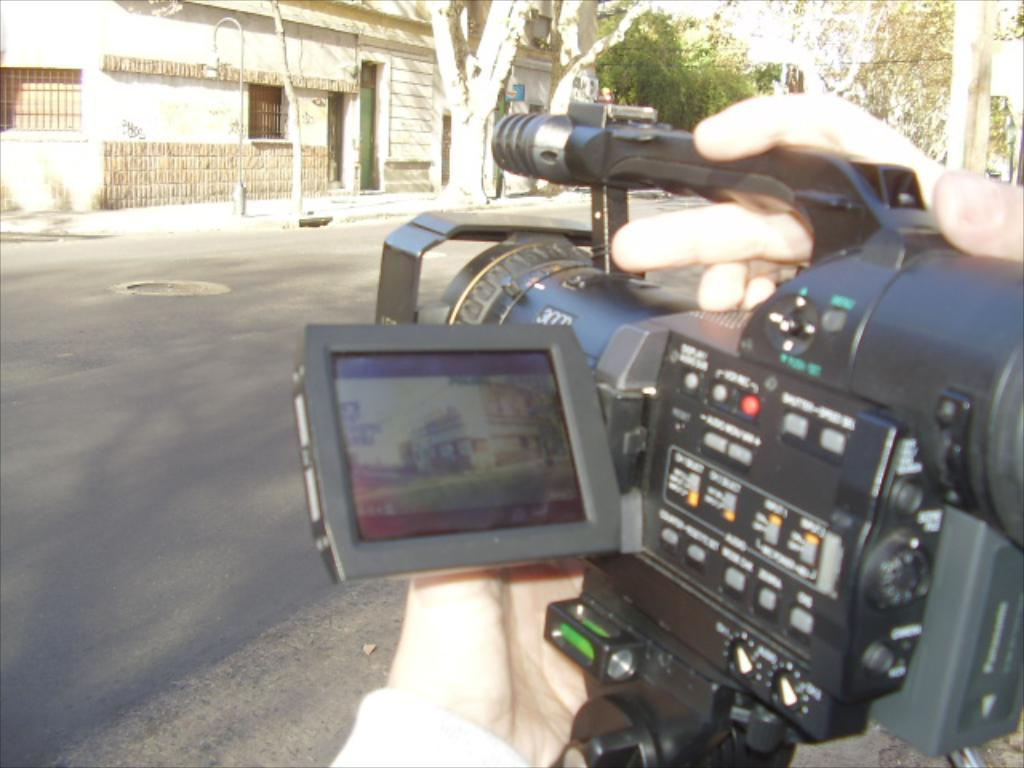What is the person in the image holding? The person in the image is holding a camera. What can be seen in the distance behind the person? There are buildings, trees, light poles, and boards in the background of the image. What is at the bottom of the image? There is a road at the bottom of the image. What type of stick does the person's sister use to play in the image? There is no sister or stick present in the image. How does the person's memory affect the image? The person's memory is not visible or relevant in the image; it is a photograph taken by the person holding the camera. 